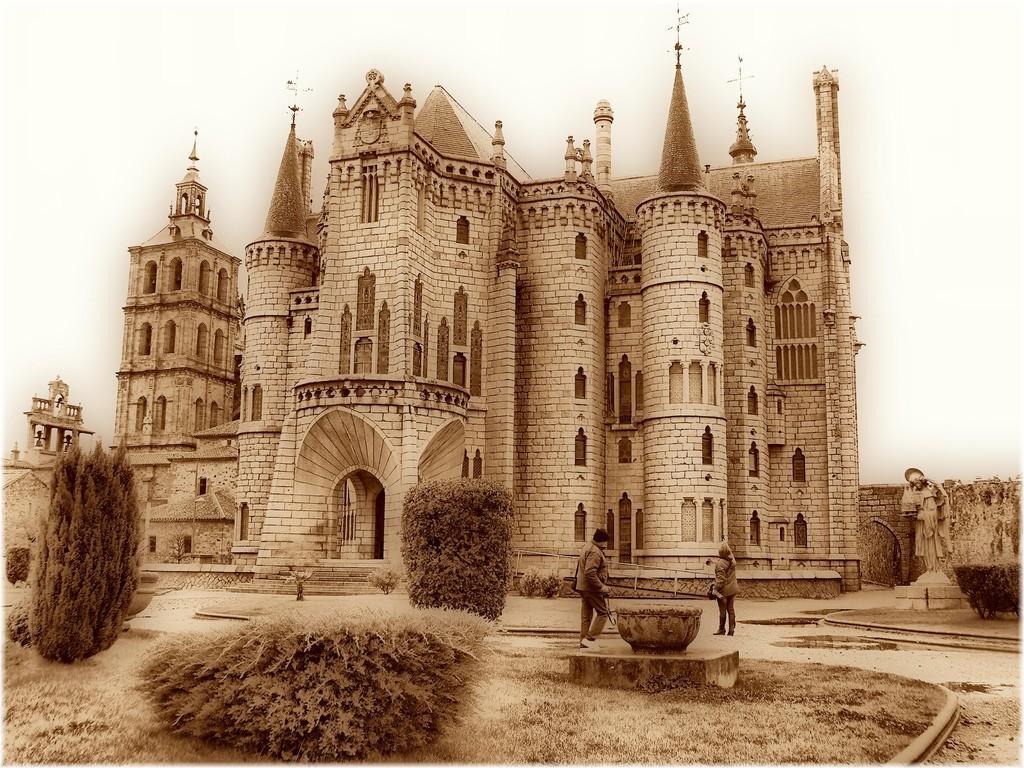Could you give a brief overview of what you see in this image? In this picture we can see two people on the ground, here we can see a building, plants, trees and some objects and we can see sky in the background. 